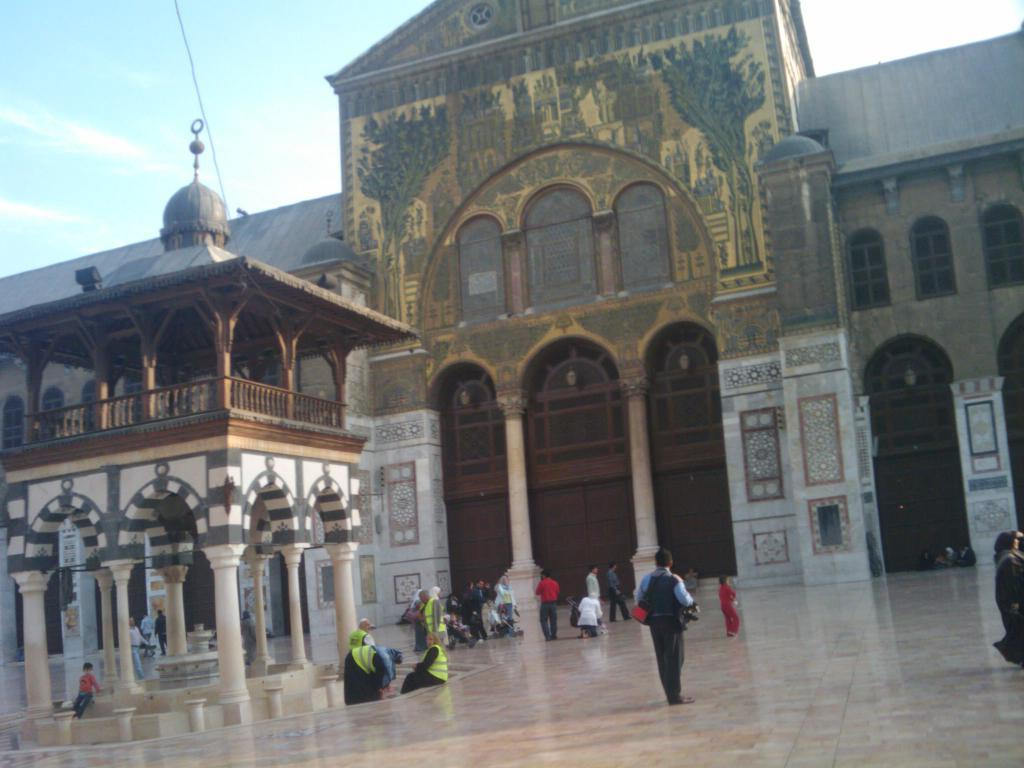What type of structure can be seen in the image? There is a building in the image. What other smaller structure is present in the image? There is a shed in the image. What architectural features can be observed in the image? There are pillars, railings, walls, and windows in the image. Can you describe the people in the image? There is a group of people in the image, with some sitting and some standing. What is visible at the top of the image? The sky is visible at the top of the image. What type of shoe can be seen on the foot of the person standing in the image? There is no foot or shoe visible in the image; only the people's positions and actions are described. 